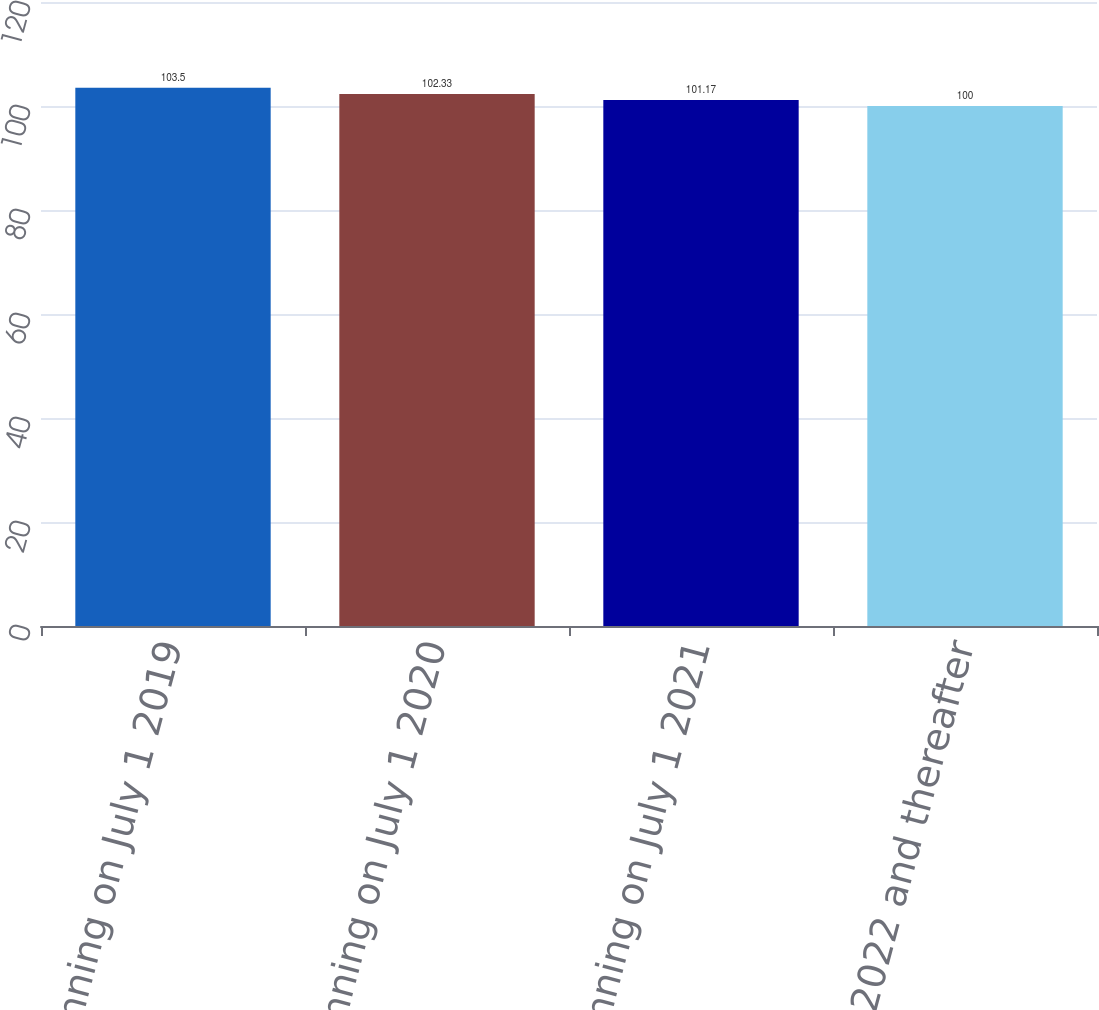Convert chart to OTSL. <chart><loc_0><loc_0><loc_500><loc_500><bar_chart><fcel>Beginning on July 1 2019<fcel>Beginning on July 1 2020<fcel>Beginning on July 1 2021<fcel>On July 1 2022 and thereafter<nl><fcel>103.5<fcel>102.33<fcel>101.17<fcel>100<nl></chart> 